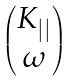<formula> <loc_0><loc_0><loc_500><loc_500>\begin{pmatrix} K _ { | | } \\ \omega \end{pmatrix}</formula> 